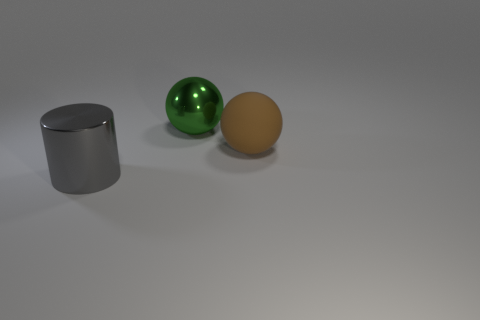What is the material of the gray object that is the same size as the green shiny ball?
Offer a terse response. Metal. Is the green object made of the same material as the brown ball?
Your answer should be very brief. No. What number of objects are either gray metallic objects or objects?
Offer a terse response. 3. What shape is the gray metal thing in front of the large green object?
Keep it short and to the point. Cylinder. What is the color of the big ball that is made of the same material as the gray cylinder?
Offer a very short reply. Green. What material is the green thing that is the same shape as the brown rubber thing?
Provide a succinct answer. Metal. There is a large gray shiny thing; what shape is it?
Offer a terse response. Cylinder. What material is the thing that is on the left side of the brown rubber object and behind the big gray metallic cylinder?
Provide a succinct answer. Metal. There is a object that is made of the same material as the large cylinder; what is its shape?
Keep it short and to the point. Sphere. There is a big thing that is both on the left side of the brown matte thing and in front of the large green metal object; what is its shape?
Provide a short and direct response. Cylinder. 